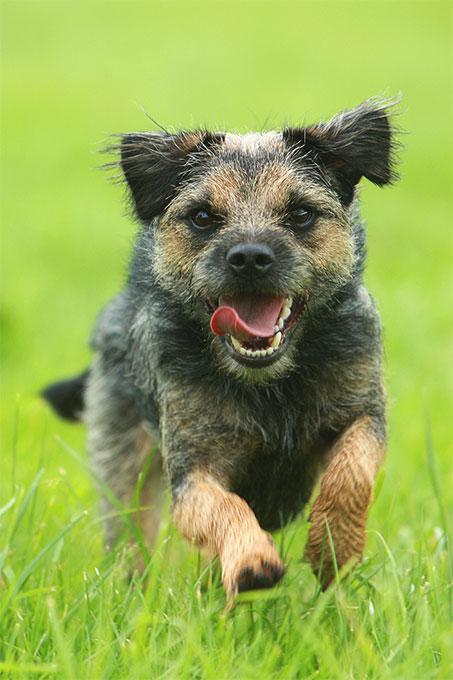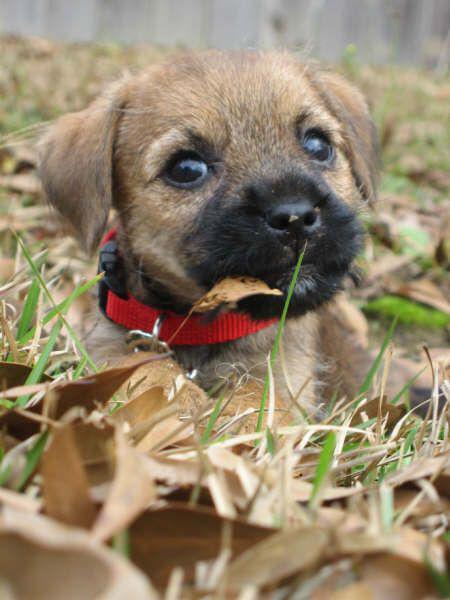The first image is the image on the left, the second image is the image on the right. Given the left and right images, does the statement "The dog in the image on the right is wearing a collar." hold true? Answer yes or no. Yes. The first image is the image on the left, the second image is the image on the right. For the images shown, is this caption "A dog posed outdoors is wearing something that buckles and extends around its neck." true? Answer yes or no. Yes. 